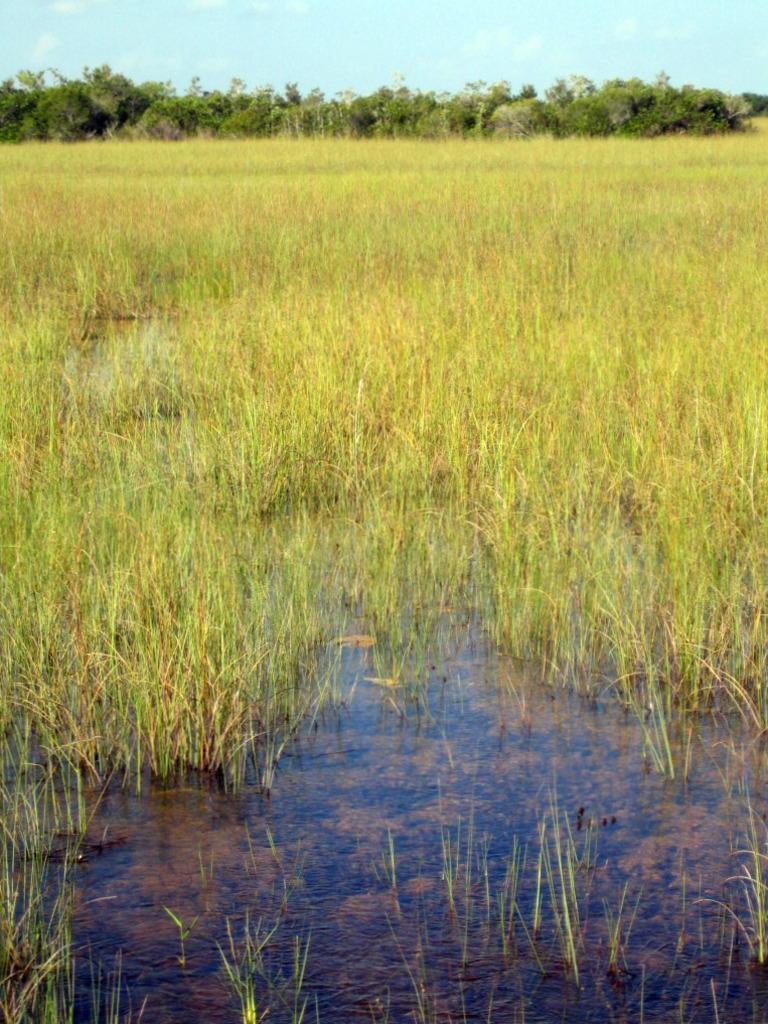Describe this image in one or two sentences. This picture shows grass on the ground and we see water and bunch of trees and a blue cloudy sky. 